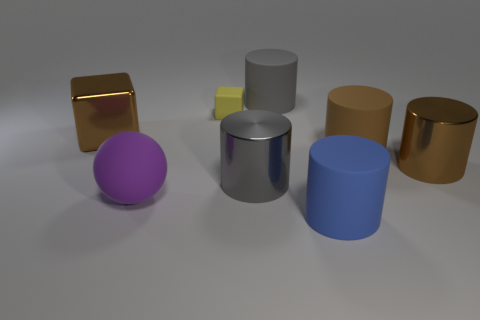Does the tiny cube have the same color as the cylinder that is to the right of the brown matte cylinder?
Provide a succinct answer. No. What is the gray cylinder that is behind the brown metallic thing that is on the left side of the large blue cylinder that is left of the big brown rubber thing made of?
Provide a short and direct response. Rubber. There is a brown shiny object on the left side of the big brown matte thing; what is its shape?
Make the answer very short. Cube. There is a gray object that is made of the same material as the big cube; what is its size?
Offer a very short reply. Large. How many yellow things are the same shape as the large blue matte thing?
Provide a short and direct response. 0. Is the color of the large metal cylinder that is on the right side of the blue object the same as the tiny object?
Your answer should be compact. No. There is a metallic cylinder in front of the brown metal object to the right of the blue rubber thing; what number of yellow matte things are behind it?
Give a very brief answer. 1. What number of large cylinders are in front of the brown matte object and left of the large blue cylinder?
Provide a short and direct response. 1. The rubber object that is the same color as the big block is what shape?
Offer a very short reply. Cylinder. Is there anything else that has the same material as the big cube?
Your answer should be very brief. Yes. 